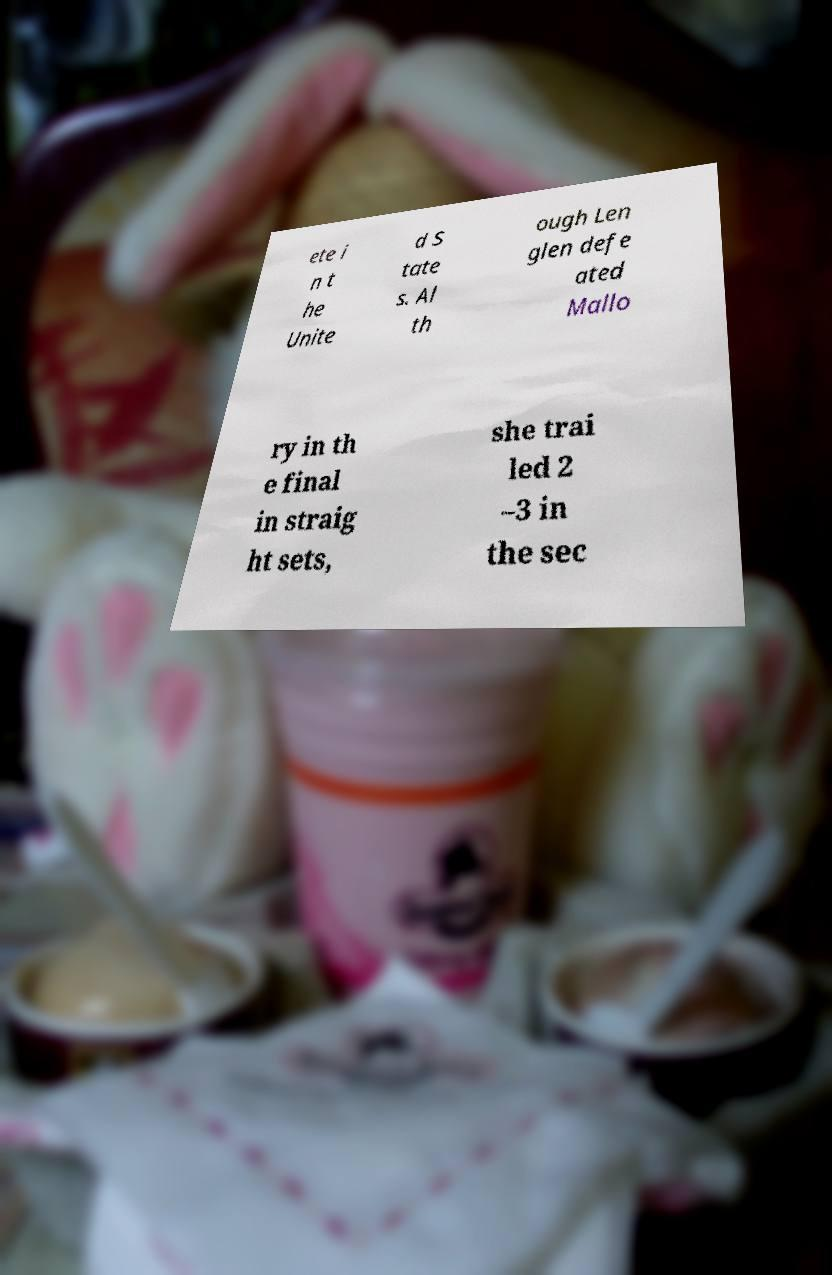Please identify and transcribe the text found in this image. ete i n t he Unite d S tate s. Al th ough Len glen defe ated Mallo ry in th e final in straig ht sets, she trai led 2 –3 in the sec 